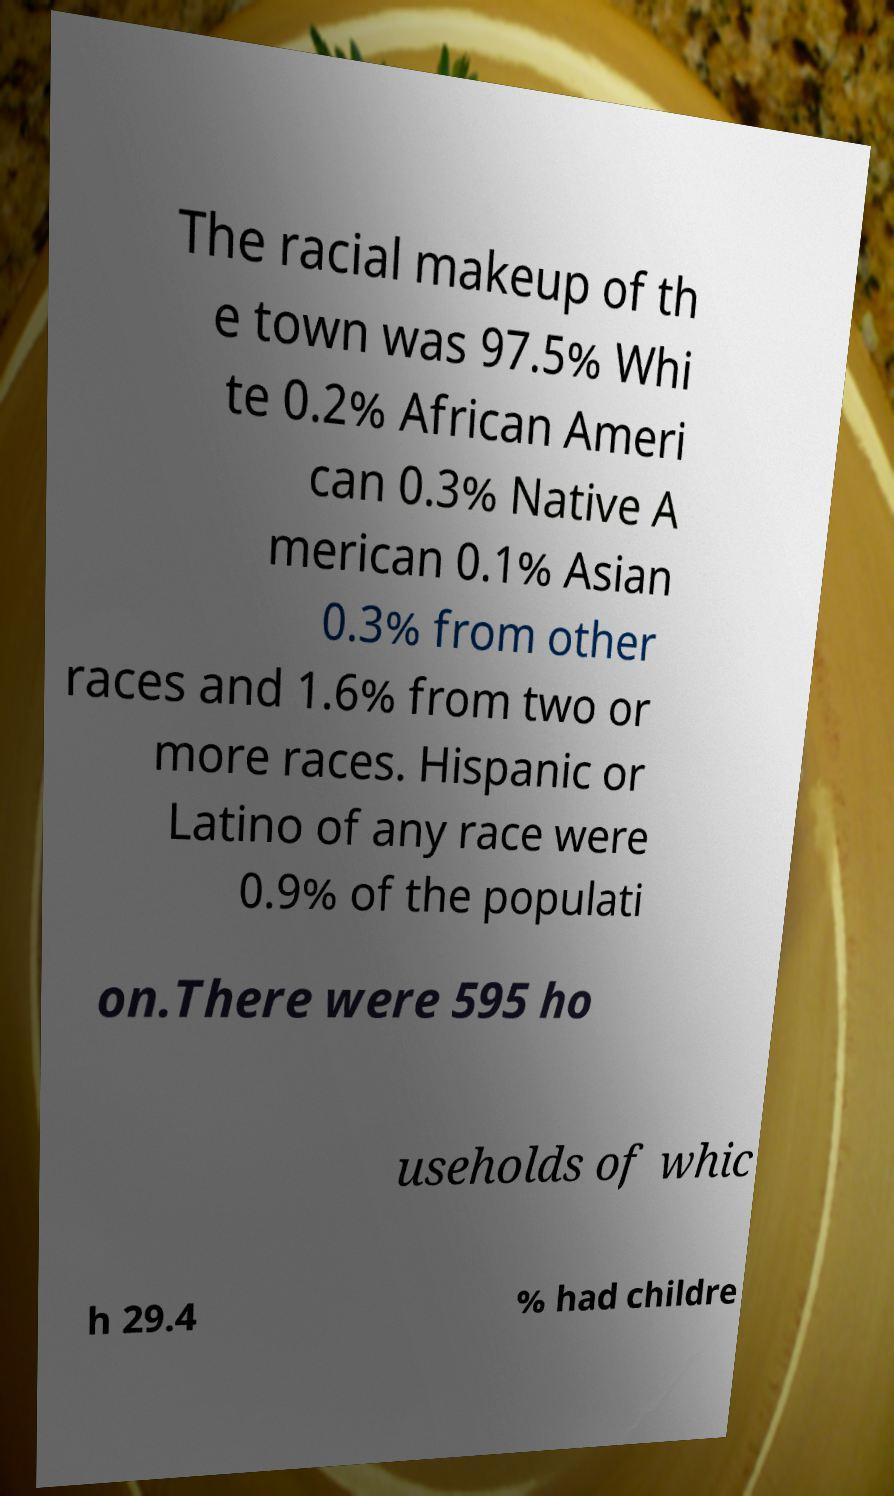Please identify and transcribe the text found in this image. The racial makeup of th e town was 97.5% Whi te 0.2% African Ameri can 0.3% Native A merican 0.1% Asian 0.3% from other races and 1.6% from two or more races. Hispanic or Latino of any race were 0.9% of the populati on.There were 595 ho useholds of whic h 29.4 % had childre 